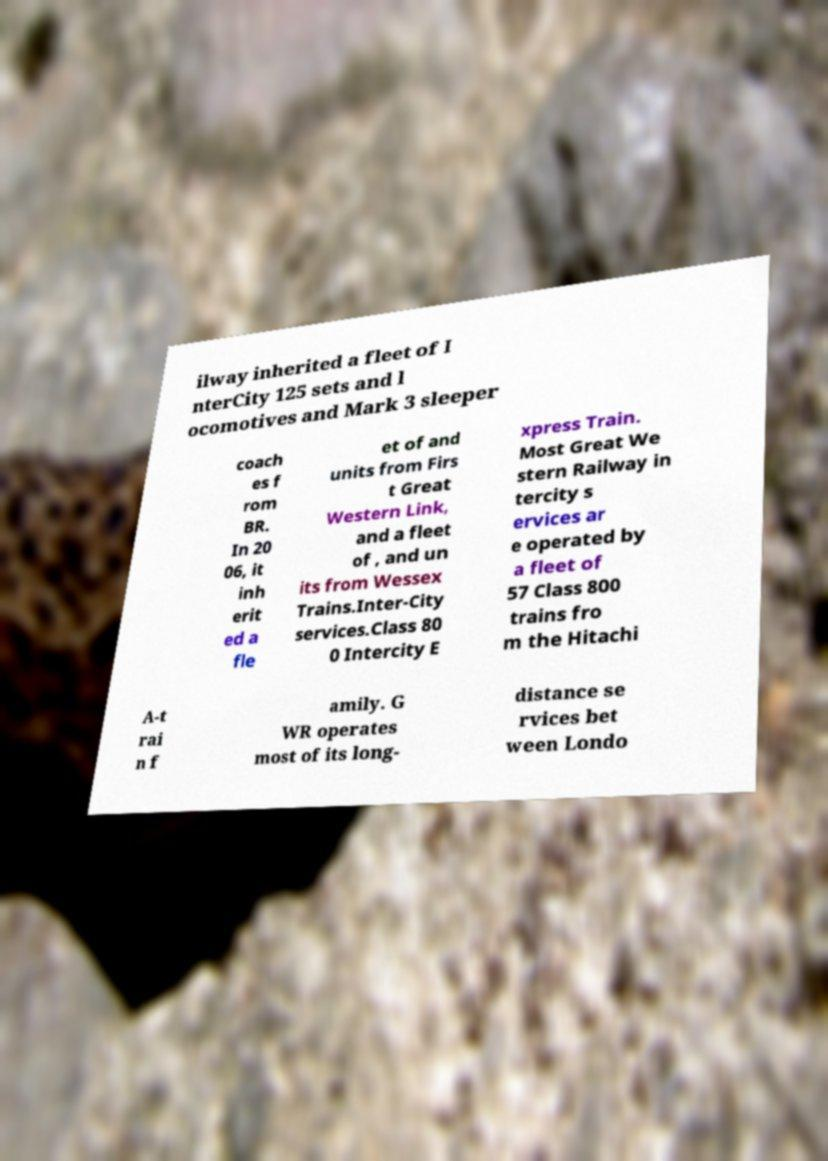Please identify and transcribe the text found in this image. ilway inherited a fleet of I nterCity 125 sets and l ocomotives and Mark 3 sleeper coach es f rom BR. In 20 06, it inh erit ed a fle et of and units from Firs t Great Western Link, and a fleet of , and un its from Wessex Trains.Inter-City services.Class 80 0 Intercity E xpress Train. Most Great We stern Railway in tercity s ervices ar e operated by a fleet of 57 Class 800 trains fro m the Hitachi A-t rai n f amily. G WR operates most of its long- distance se rvices bet ween Londo 